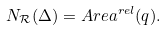<formula> <loc_0><loc_0><loc_500><loc_500>N _ { \mathcal { R } } ( \Delta ) = A r e a ^ { r e l } ( q ) .</formula> 